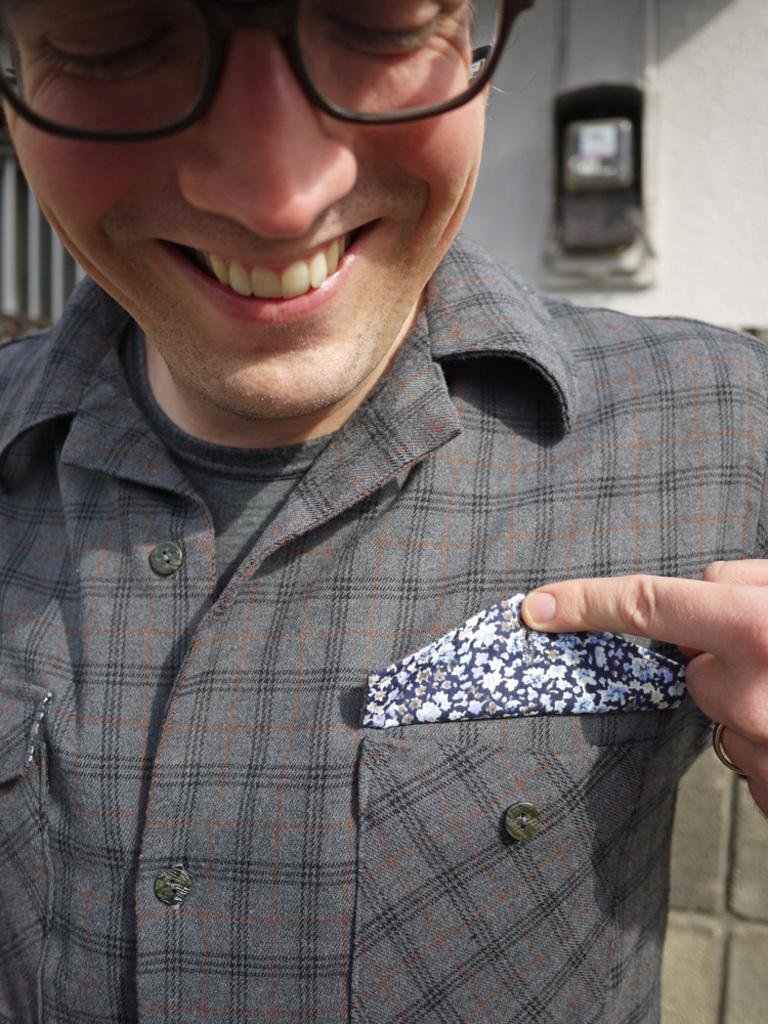Who is present in the image? There is a person in the image. What is the person doing in the image? The person is smiling. What is the person wearing in the image? The person is wearing an ash-colored dress. What can be seen in the background of the image? There are objects visible in the background of the image. What type of cheese is the person holding in the image? There is no cheese present in the image. What expertise does the person have in the image? The image does not provide any information about the person's expertise. 